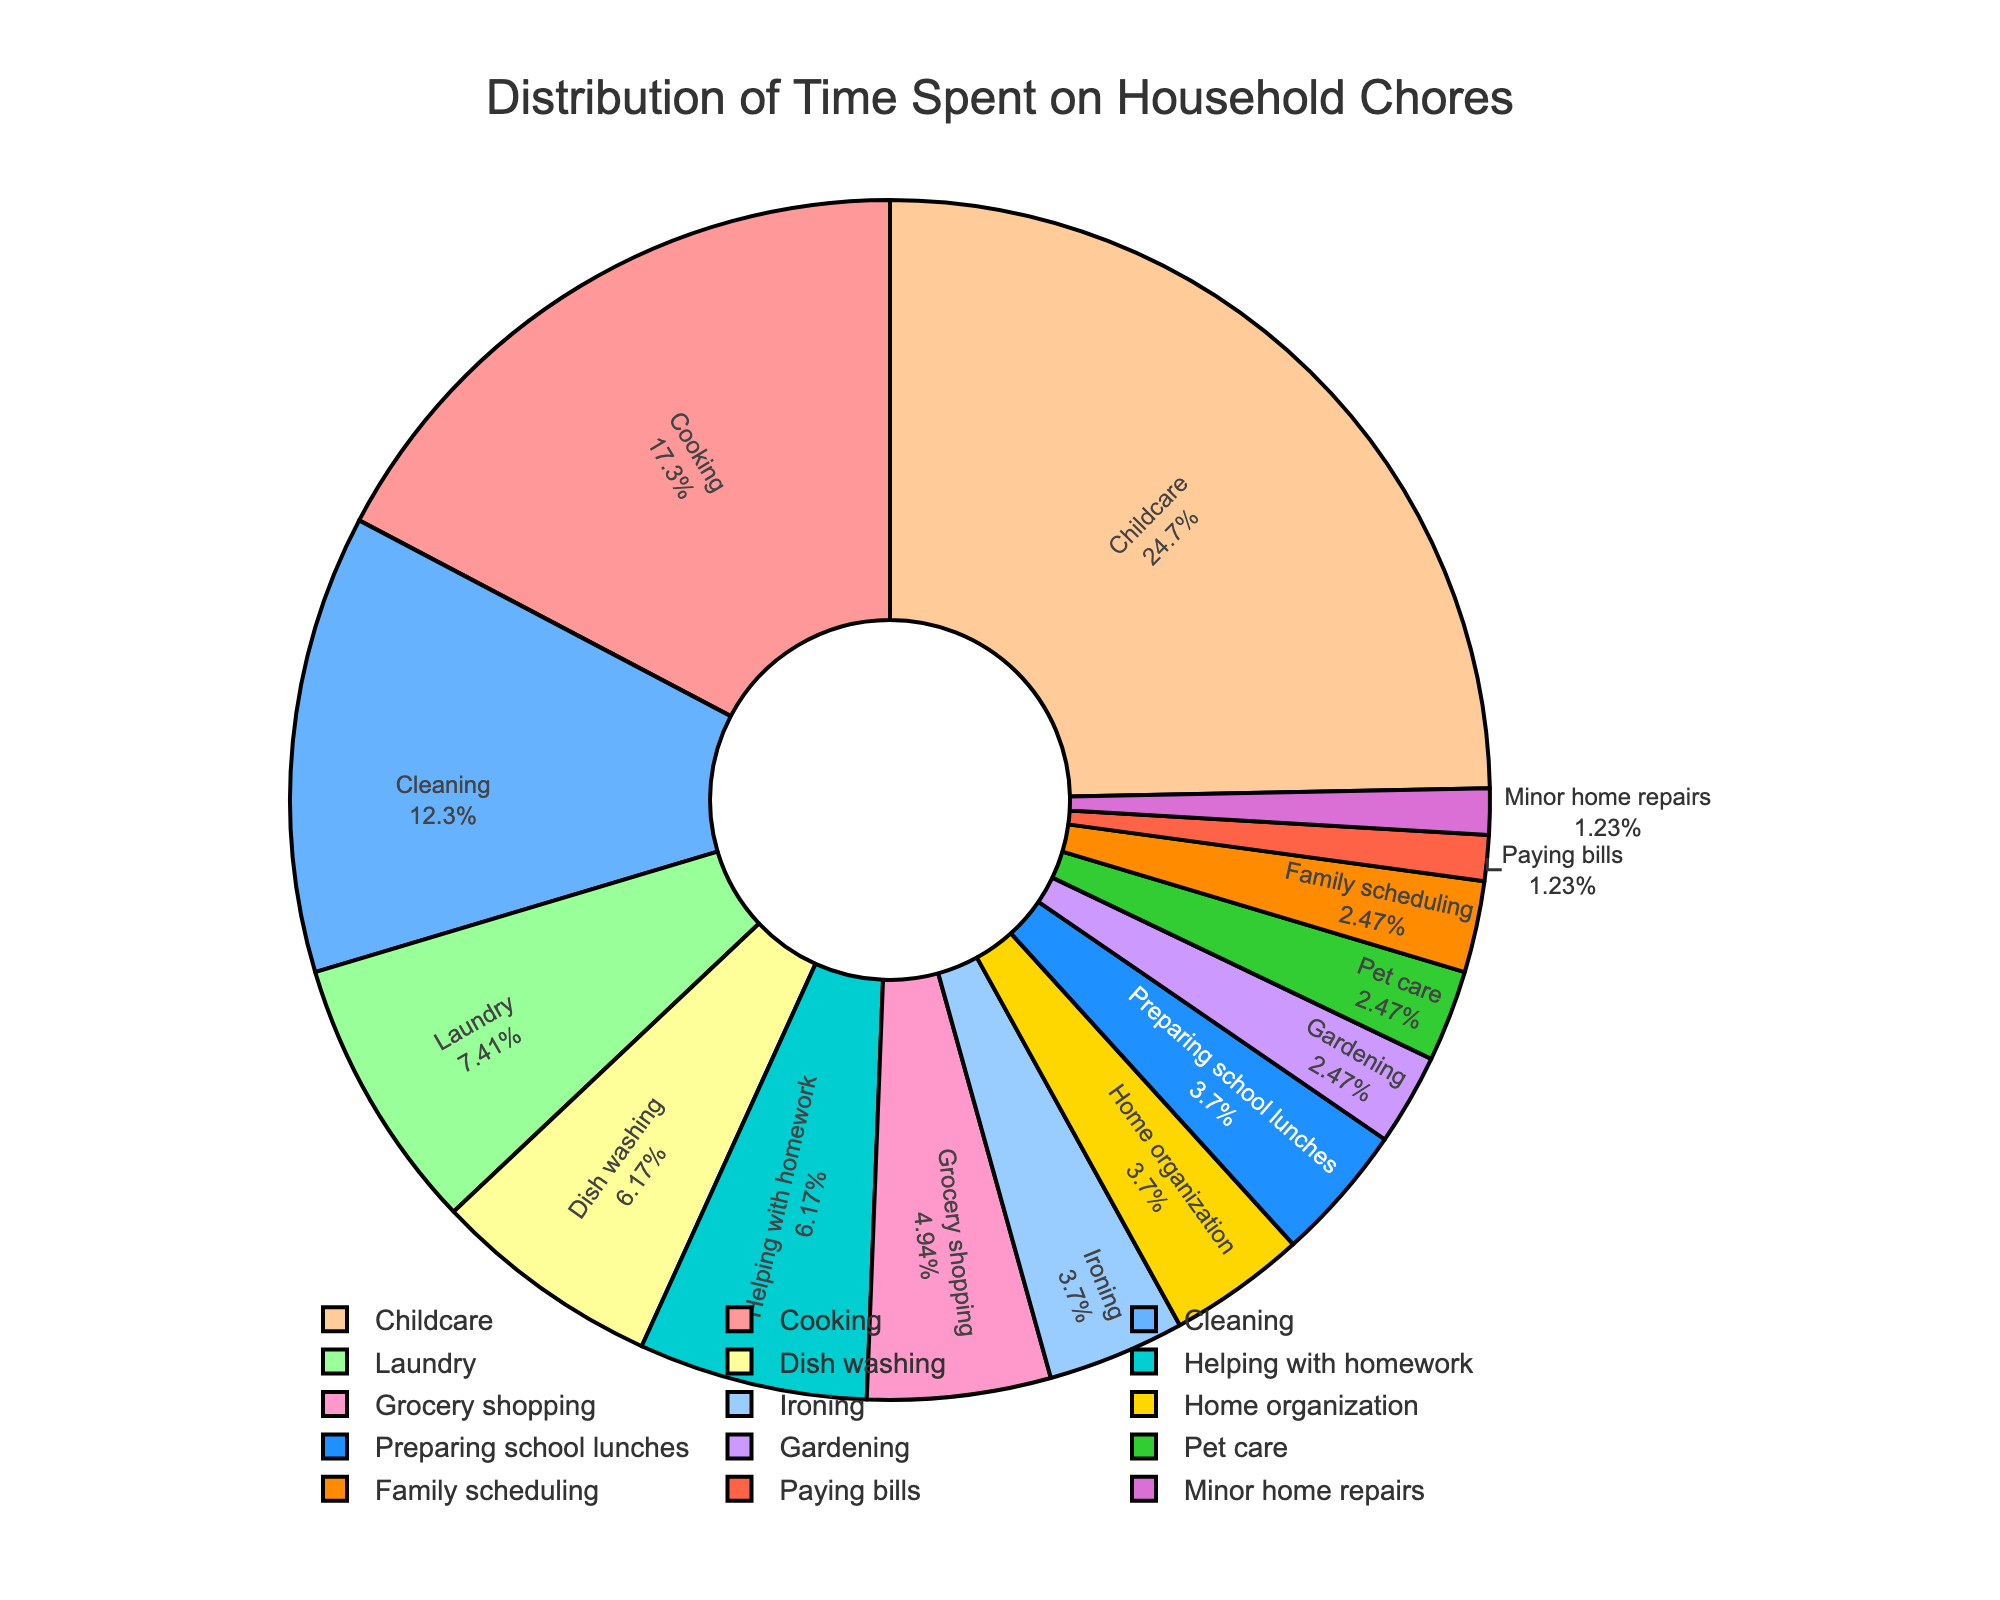What activity takes up the majority of the time per week? Look at the pie chart and identify the activity with the largest slice. Childcare has the largest percentage and slice.
Answer: Childcare Which activity takes up the least amount of time per week? Check the smallest slice on the pie chart. Paying bills and minor home repairs both have the smallest slices.
Answer: Paying bills and minor home repairs How many hours per week are spent on cooking and laundry combined? Add the hours spent on cooking (14) and the hours spent on laundry (6). 14 + 6 = 20 hours
Answer: 20 hours Which activity takes more time: cleaning or dish washing, and by how much? Compare the hours spent on cleaning (10) and dish washing (5). Cleaning takes 10 - 5 = 5 more hours than dish washing.
Answer: Cleaning by 5 hours Are more hours spent on grocery shopping or gardening? Look at the slices for grocery shopping and gardening. Grocery shopping is 4 hours, and gardening is 2 hours. Grocery shopping takes more time.
Answer: Grocery shopping What is the total amount of time spent on ironing, home organization, and preparing school lunches combined? Add the hours for ironing (3), home organization (3), and preparing school lunches (3). 3 + 3 + 3 = 9 hours
Answer: 9 hours Which takes more time: helping with homework, pet care, or family scheduling? Compare the slices for helping with homework (5), pet care (2), and family scheduling (2). Helping with homework takes the most time.
Answer: Helping with homework Is the time spent on childcare more than double the time spent on cleaning? Double the hours spent on cleaning (10 * 2 = 20) and compare with the hours spent on childcare (20). Both are the same.
Answer: No What percentage of time is spent on cooking? Look at the pie chart for the percentage next to cooking. Cooking takes up 15.1% of the total time.
Answer: 15.1% How much more time is spent on childcare than on paying bills and minor home repairs combined? Sum the hours for paying bills (1) and minor home repairs (1), which is 2 hours. The difference is 20 (childcare) - 2 = 18 hours.
Answer: 18 hours 